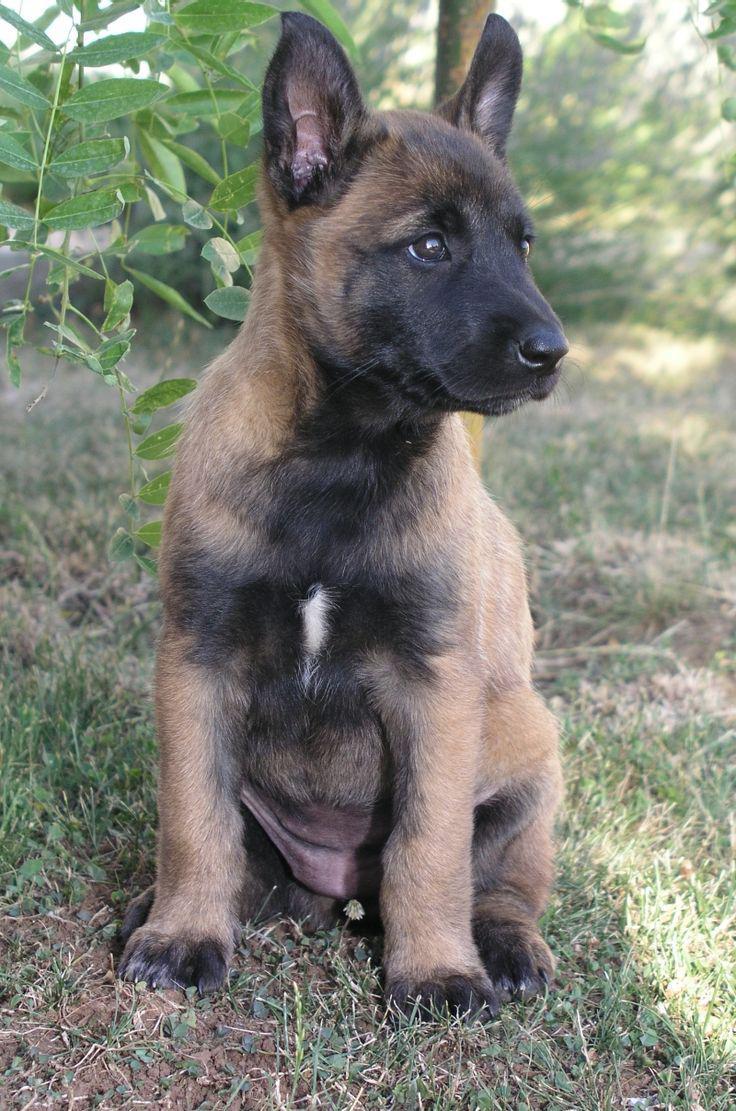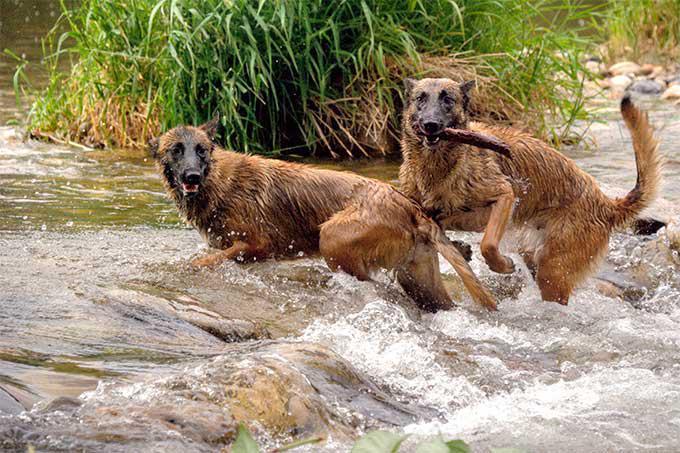The first image is the image on the left, the second image is the image on the right. Examine the images to the left and right. Is the description "At least one dog is wearing a leash." accurate? Answer yes or no. No. The first image is the image on the left, the second image is the image on the right. For the images shown, is this caption "A puppy is running through the grass toward the camera." true? Answer yes or no. No. 